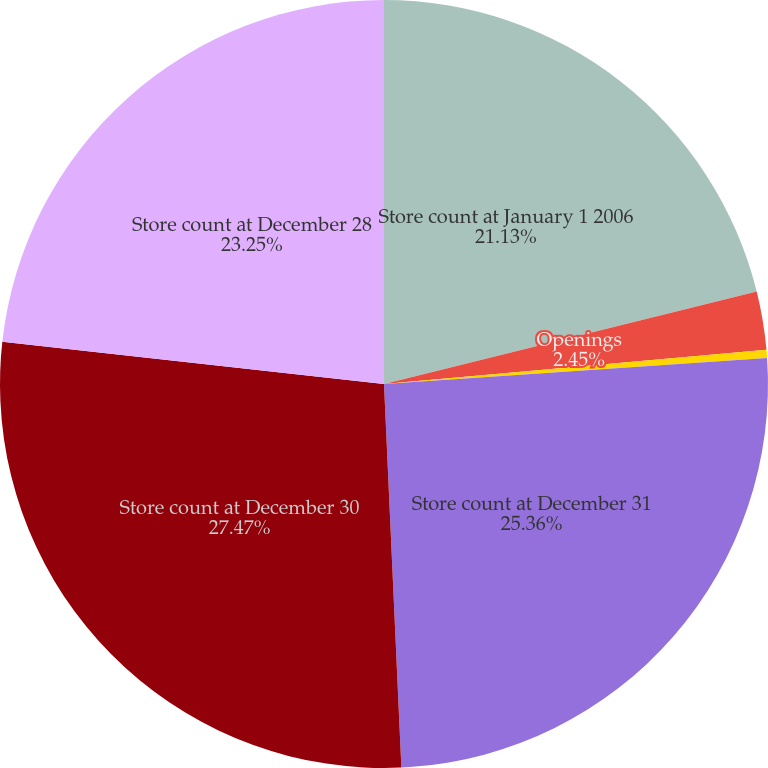Convert chart to OTSL. <chart><loc_0><loc_0><loc_500><loc_500><pie_chart><fcel>Store count at January 1 2006<fcel>Openings<fcel>Closings<fcel>Store count at December 31<fcel>Store count at December 30<fcel>Store count at December 28<nl><fcel>21.13%<fcel>2.45%<fcel>0.34%<fcel>25.36%<fcel>27.47%<fcel>23.25%<nl></chart> 